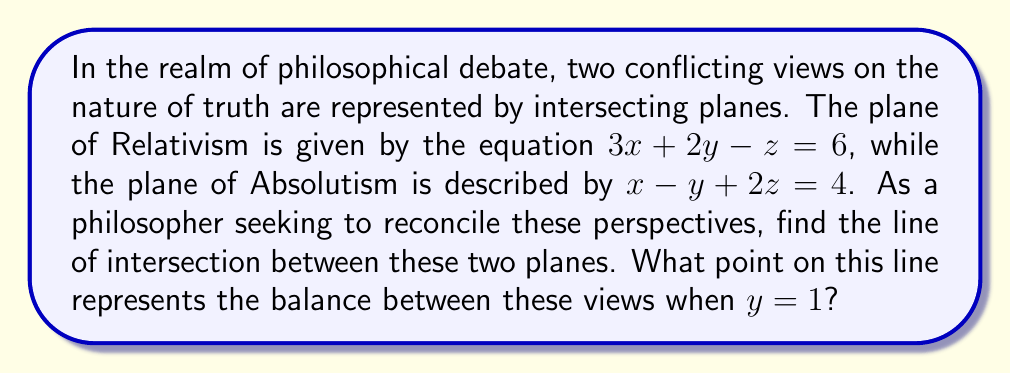Can you answer this question? To find the intersection of the two planes, we need to solve their equations simultaneously:

1) First, let's write out our plane equations:
   Relativism: $3x + 2y - z = 6$ ... (1)
   Absolutism: $x - y + 2z = 4$ ... (2)

2) To find the line of intersection, we need to express z and x in terms of y:

3) From equation (2), we can express x:
   $x = 4 + y - 2z$ ... (3)

4) Substitute this into equation (1):
   $3(4 + y - 2z) + 2y - z = 6$
   $12 + 3y - 6z + 2y - z = 6$
   $12 + 5y - 7z = 6$
   $5y - 7z = -6$ ... (4)

5) Now we have two equations in terms of y and z:
   $5y - 7z = -6$ ... (4)
   $x - y + 2z = 4$ ... (2)

6) These represent the line of intersection. To find the point where $y = 1$, substitute this into equation (4):
   $5(1) - 7z = -6$
   $5 - 7z = -6$
   $-7z = -11$
   $z = \frac{11}{7}$

7) Now substitute $y = 1$ and $z = \frac{11}{7}$ into equation (2):
   $x - 1 + 2(\frac{11}{7}) = 4$
   $x + \frac{22}{7} - 1 = 4$
   $x = 4 - \frac{22}{7} + 1 = \frac{35}{7} - \frac{22}{7} + \frac{7}{7} = \frac{20}{7}$

Therefore, the point of balance when $y = 1$ is $(\frac{20}{7}, 1, \frac{11}{7})$.
Answer: $(\frac{20}{7}, 1, \frac{11}{7})$ 